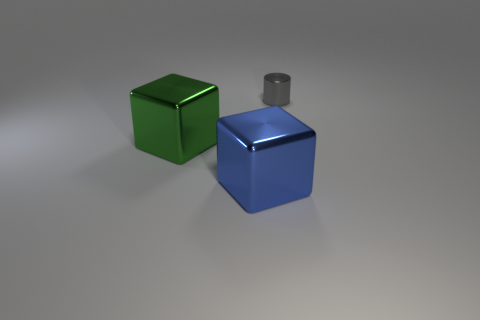Add 2 big gray cylinders. How many objects exist? 5 Subtract all blocks. How many objects are left? 1 Subtract all gray objects. Subtract all big blue shiny objects. How many objects are left? 1 Add 1 big green blocks. How many big green blocks are left? 2 Add 2 big blue metal cubes. How many big blue metal cubes exist? 3 Subtract 1 blue blocks. How many objects are left? 2 